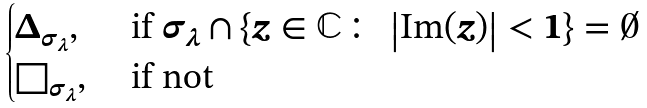Convert formula to latex. <formula><loc_0><loc_0><loc_500><loc_500>\begin{cases} \Delta _ { \sigma _ { \lambda } } , & \text { if } \sigma _ { \lambda } \cap \left \{ z \in \mathbb { C } \colon \, \left | \text {Im} ( z ) \right | < 1 \right \} = \emptyset \\ \square _ { \sigma _ { \lambda } } , & \text { if not} \end{cases}</formula> 